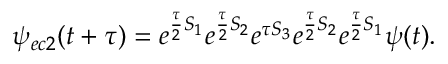Convert formula to latex. <formula><loc_0><loc_0><loc_500><loc_500>\psi _ { e c 2 } ( t + \tau ) = e ^ { \frac { \tau } { 2 } S _ { 1 } } e ^ { \frac { \tau } { 2 } S _ { 2 } } e ^ { \tau S _ { 3 } } e ^ { \frac { \tau } { 2 } S _ { 2 } } e ^ { \frac { \tau } { 2 } S _ { 1 } } \psi ( t ) .</formula> 